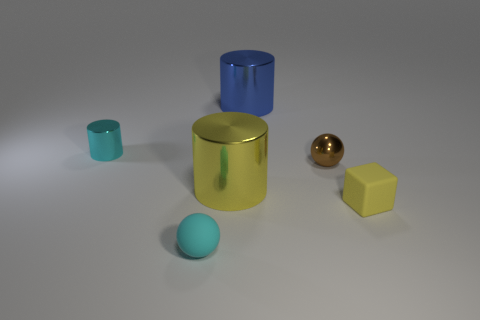Subtract all large shiny cylinders. How many cylinders are left? 1 Add 4 small cylinders. How many objects exist? 10 Subtract all cubes. How many objects are left? 5 Add 3 tiny cubes. How many tiny cubes exist? 4 Subtract 1 cyan cylinders. How many objects are left? 5 Subtract all large metal cylinders. Subtract all tiny rubber cylinders. How many objects are left? 4 Add 2 matte blocks. How many matte blocks are left? 3 